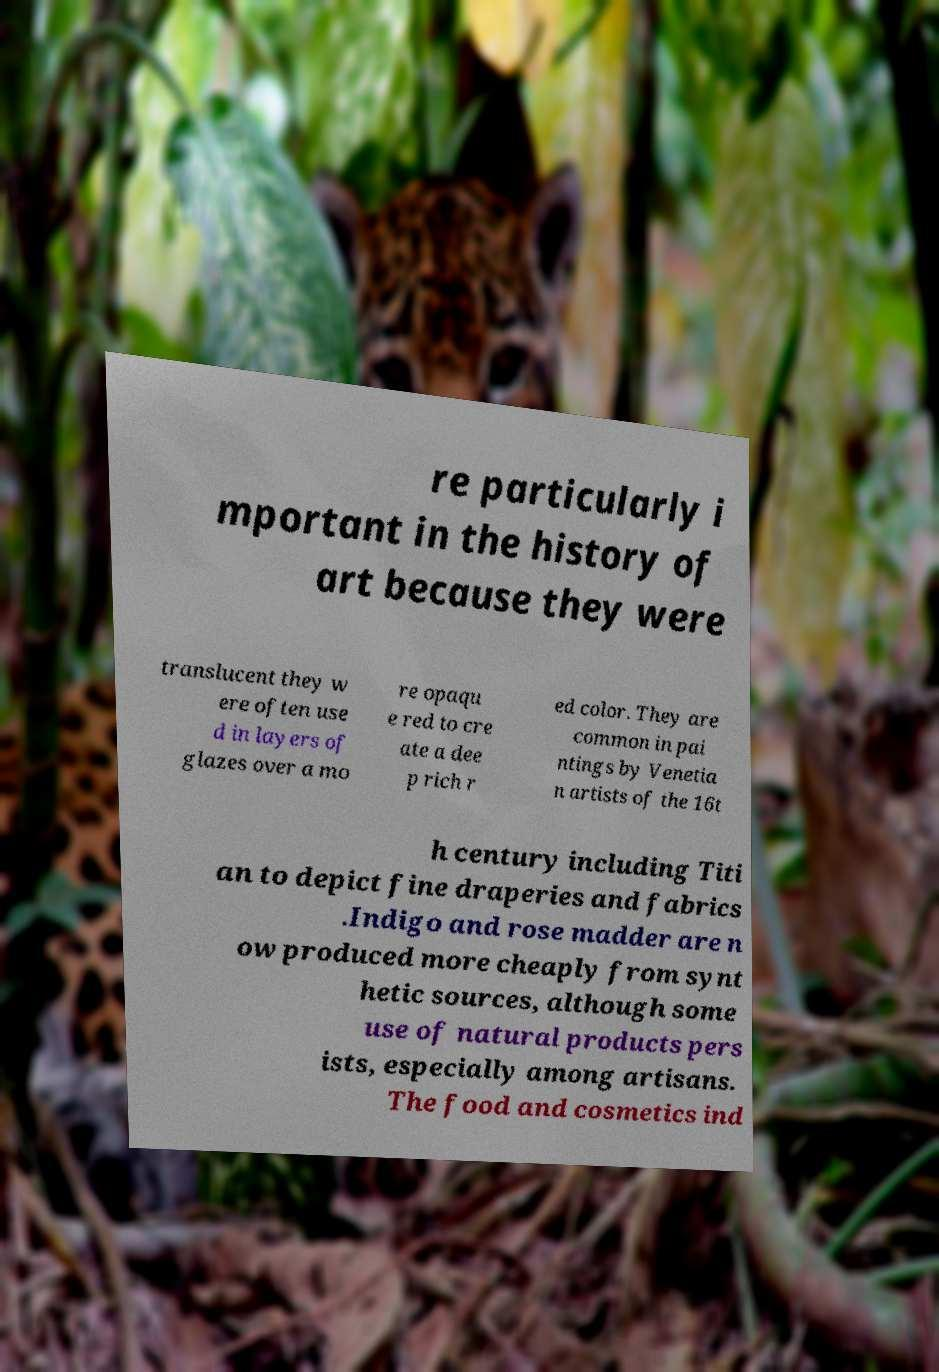What messages or text are displayed in this image? I need them in a readable, typed format. re particularly i mportant in the history of art because they were translucent they w ere often use d in layers of glazes over a mo re opaqu e red to cre ate a dee p rich r ed color. They are common in pai ntings by Venetia n artists of the 16t h century including Titi an to depict fine draperies and fabrics .Indigo and rose madder are n ow produced more cheaply from synt hetic sources, although some use of natural products pers ists, especially among artisans. The food and cosmetics ind 